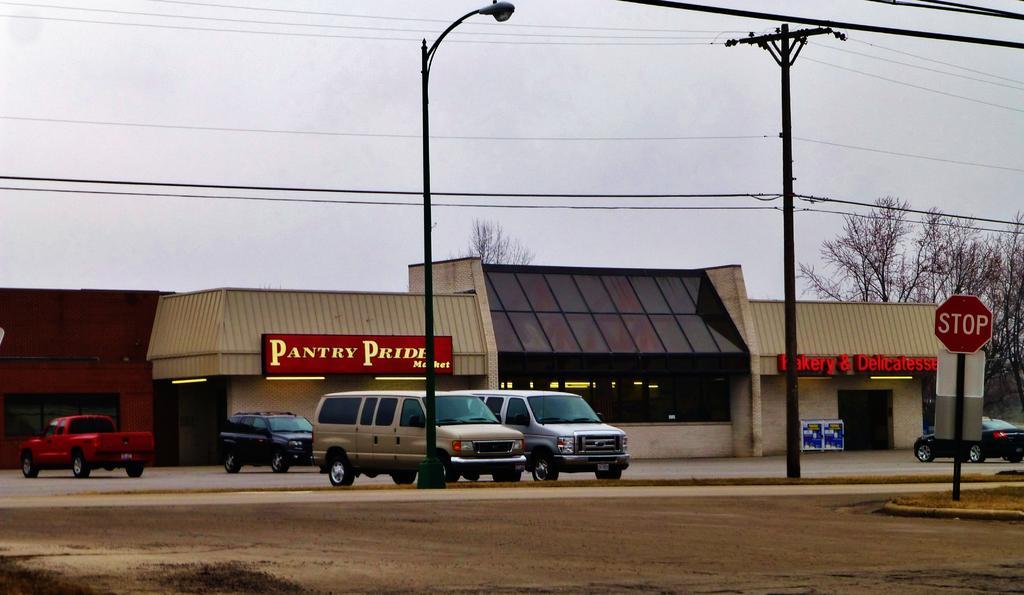Describe this image in one or two sentences. In the image there are few cars on the road, In the back there is a building with trees behind it, in the front there are electric poles and above its sky. 